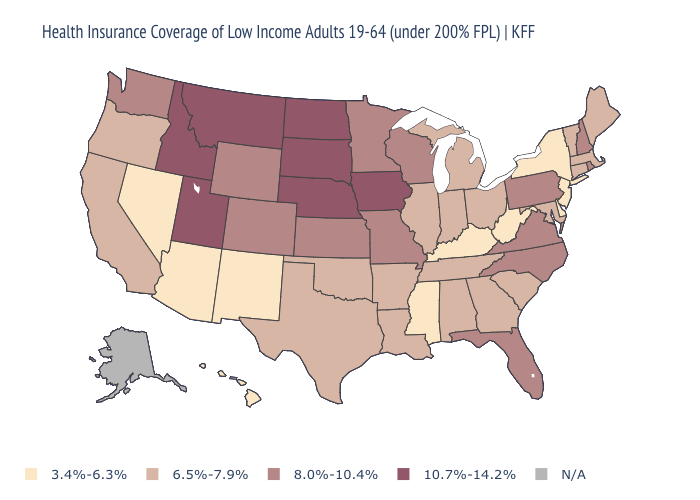How many symbols are there in the legend?
Write a very short answer. 5. What is the highest value in the USA?
Quick response, please. 10.7%-14.2%. Which states have the lowest value in the South?
Write a very short answer. Delaware, Kentucky, Mississippi, West Virginia. What is the lowest value in the USA?
Give a very brief answer. 3.4%-6.3%. Name the states that have a value in the range N/A?
Quick response, please. Alaska. What is the value of Minnesota?
Quick response, please. 8.0%-10.4%. Name the states that have a value in the range 10.7%-14.2%?
Keep it brief. Idaho, Iowa, Montana, Nebraska, North Dakota, South Dakota, Utah. Does New York have the lowest value in the USA?
Give a very brief answer. Yes. Which states hav the highest value in the South?
Give a very brief answer. Florida, North Carolina, Virginia. Name the states that have a value in the range 3.4%-6.3%?
Quick response, please. Arizona, Delaware, Hawaii, Kentucky, Mississippi, Nevada, New Jersey, New Mexico, New York, West Virginia. What is the value of Kansas?
Keep it brief. 8.0%-10.4%. What is the value of New York?
Keep it brief. 3.4%-6.3%. 